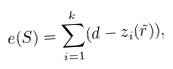Convert formula to latex. <formula><loc_0><loc_0><loc_500><loc_500>e ( S ) = \sum _ { i = 1 } ^ { k } ( d - z _ { i } ( \tilde { r } ) ) ,</formula> 